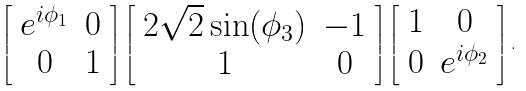<formula> <loc_0><loc_0><loc_500><loc_500>\left [ \begin{array} [ c ] { c c } e ^ { i \phi _ { 1 } } & 0 \\ 0 & 1 \end{array} \right ] \left [ \begin{array} [ c ] { c c } 2 \sqrt { 2 } \sin ( \phi _ { 3 } ) & - 1 \\ 1 & 0 \end{array} \right ] \left [ \begin{array} [ c ] { c c } 1 & 0 \\ 0 & e ^ { i \phi _ { 2 } } \end{array} \right ] .</formula> 